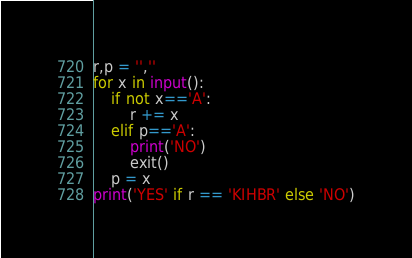<code> <loc_0><loc_0><loc_500><loc_500><_Python_>r,p = '',''
for x in input():
	if not x=='A':
		r += x
	elif p=='A':
		print('NO')
		exit()
	p = x
print('YES' if r == 'KIHBR' else 'NO')</code> 